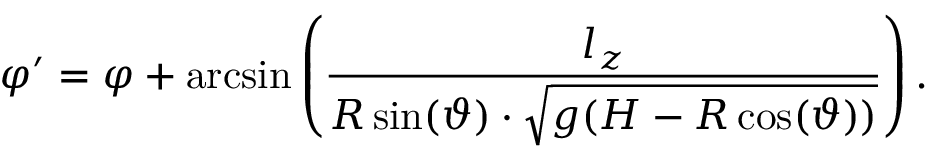<formula> <loc_0><loc_0><loc_500><loc_500>\varphi ^ { \prime } = \varphi + \arcsin \left ( \frac { l _ { z } } { R \sin ( \vartheta ) \cdot \sqrt { g ( H - R \cos ( \vartheta ) ) } } \right ) .</formula> 